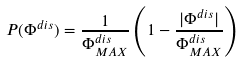<formula> <loc_0><loc_0><loc_500><loc_500>P ( \Phi ^ { d i s } ) = \frac { 1 } { \Phi ^ { d i s } _ { M A X } } \left ( 1 - \frac { | \Phi ^ { d i s } | } { \Phi ^ { d i s } _ { M A X } } \right )</formula> 